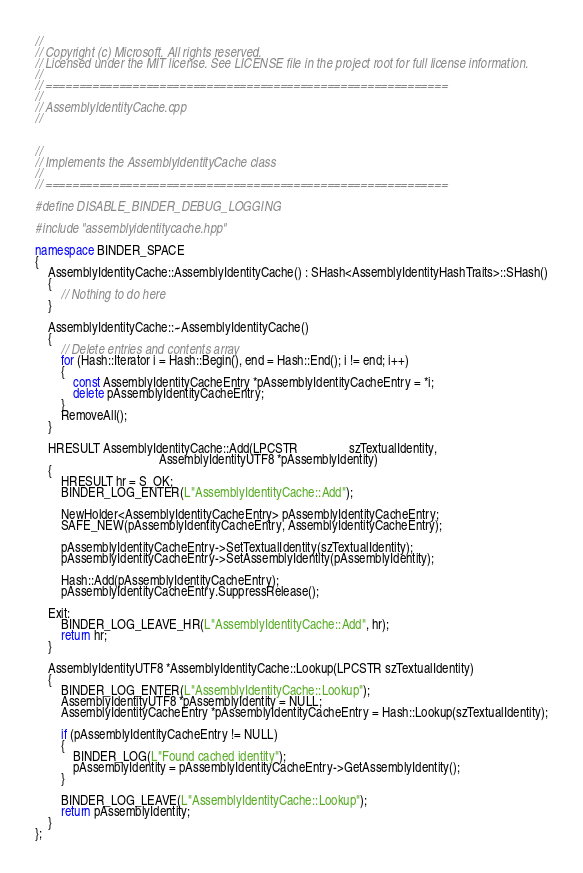Convert code to text. <code><loc_0><loc_0><loc_500><loc_500><_C++_>//
// Copyright (c) Microsoft. All rights reserved.
// Licensed under the MIT license. See LICENSE file in the project root for full license information.
//
// ============================================================
//
// AssemblyIdentityCache.cpp
//


//
// Implements the AssemblyIdentityCache class
//
// ============================================================

#define DISABLE_BINDER_DEBUG_LOGGING

#include "assemblyidentitycache.hpp"

namespace BINDER_SPACE
{
    AssemblyIdentityCache::AssemblyIdentityCache() : SHash<AssemblyIdentityHashTraits>::SHash()
    {
        // Nothing to do here
    }

    AssemblyIdentityCache::~AssemblyIdentityCache()
    {
        // Delete entries and contents array
        for (Hash::Iterator i = Hash::Begin(), end = Hash::End(); i != end; i++)
        {
            const AssemblyIdentityCacheEntry *pAssemblyIdentityCacheEntry = *i;
            delete pAssemblyIdentityCacheEntry;
        }
        RemoveAll();
    }

    HRESULT AssemblyIdentityCache::Add(LPCSTR                szTextualIdentity,
                                       AssemblyIdentityUTF8 *pAssemblyIdentity)
    {
        HRESULT hr = S_OK;
        BINDER_LOG_ENTER(L"AssemblyIdentityCache::Add");

        NewHolder<AssemblyIdentityCacheEntry> pAssemblyIdentityCacheEntry;
        SAFE_NEW(pAssemblyIdentityCacheEntry, AssemblyIdentityCacheEntry);

        pAssemblyIdentityCacheEntry->SetTextualIdentity(szTextualIdentity);
        pAssemblyIdentityCacheEntry->SetAssemblyIdentity(pAssemblyIdentity);
        
        Hash::Add(pAssemblyIdentityCacheEntry);
        pAssemblyIdentityCacheEntry.SuppressRelease();

    Exit:
        BINDER_LOG_LEAVE_HR(L"AssemblyIdentityCache::Add", hr);
        return hr;
    }

    AssemblyIdentityUTF8 *AssemblyIdentityCache::Lookup(LPCSTR szTextualIdentity)
    {
        BINDER_LOG_ENTER(L"AssemblyIdentityCache::Lookup");
        AssemblyIdentityUTF8 *pAssemblyIdentity = NULL;
        AssemblyIdentityCacheEntry *pAssemblyIdentityCacheEntry = Hash::Lookup(szTextualIdentity);

        if (pAssemblyIdentityCacheEntry != NULL)
        {
            BINDER_LOG(L"Found cached identity");
            pAssemblyIdentity = pAssemblyIdentityCacheEntry->GetAssemblyIdentity();
        }

        BINDER_LOG_LEAVE(L"AssemblyIdentityCache::Lookup");
        return pAssemblyIdentity;
    }
};
</code> 